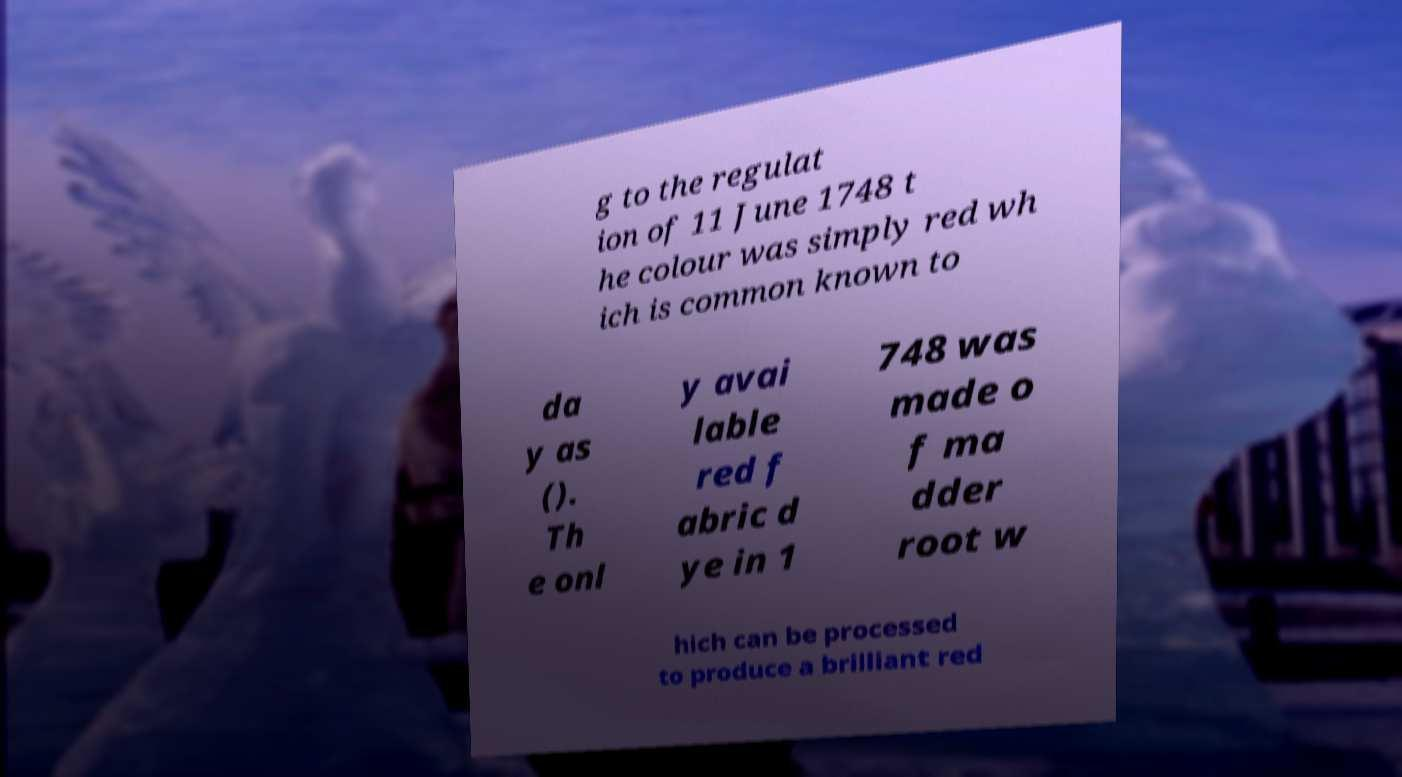Could you extract and type out the text from this image? g to the regulat ion of 11 June 1748 t he colour was simply red wh ich is common known to da y as (). Th e onl y avai lable red f abric d ye in 1 748 was made o f ma dder root w hich can be processed to produce a brilliant red 